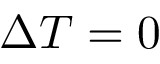Convert formula to latex. <formula><loc_0><loc_0><loc_500><loc_500>\Delta T = 0</formula> 